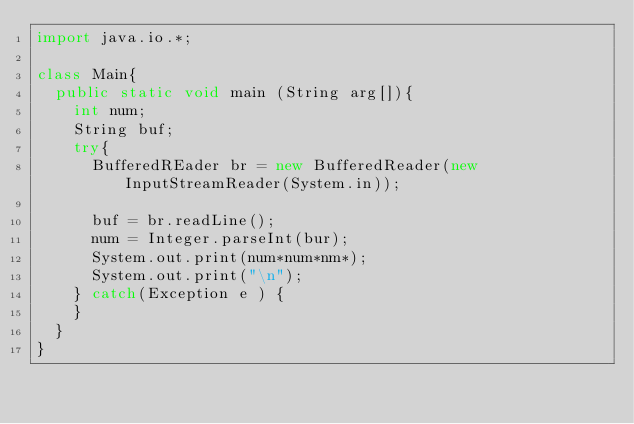Convert code to text. <code><loc_0><loc_0><loc_500><loc_500><_Java_>import java.io.*;

class Main{
	public static void main (String arg[]){
		int num;
		String buf;
		try{
			BufferedREader br = new BufferedReader(new InputStreamReader(System.in));
			
			buf = br.readLine();
			num = Integer.parseInt(bur);
			System.out.print(num*num*nm*);
			System.out.print("\n");
		} catch(Exception e ) {
		}
	}
}</code> 